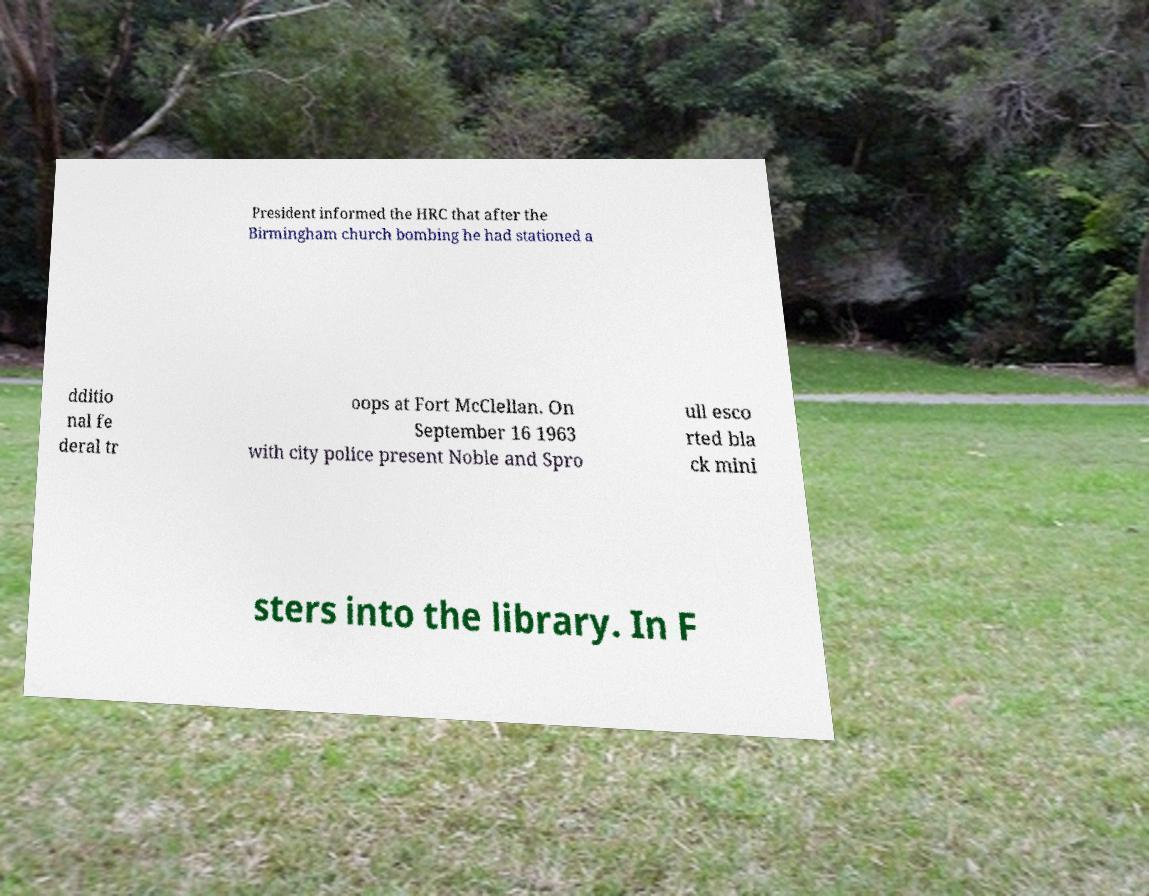Please read and relay the text visible in this image. What does it say? President informed the HRC that after the Birmingham church bombing he had stationed a dditio nal fe deral tr oops at Fort McClellan. On September 16 1963 with city police present Noble and Spro ull esco rted bla ck mini sters into the library. In F 